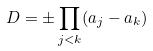<formula> <loc_0><loc_0><loc_500><loc_500>D = \pm \prod _ { j < k } ( a _ { j } - a _ { k } )</formula> 